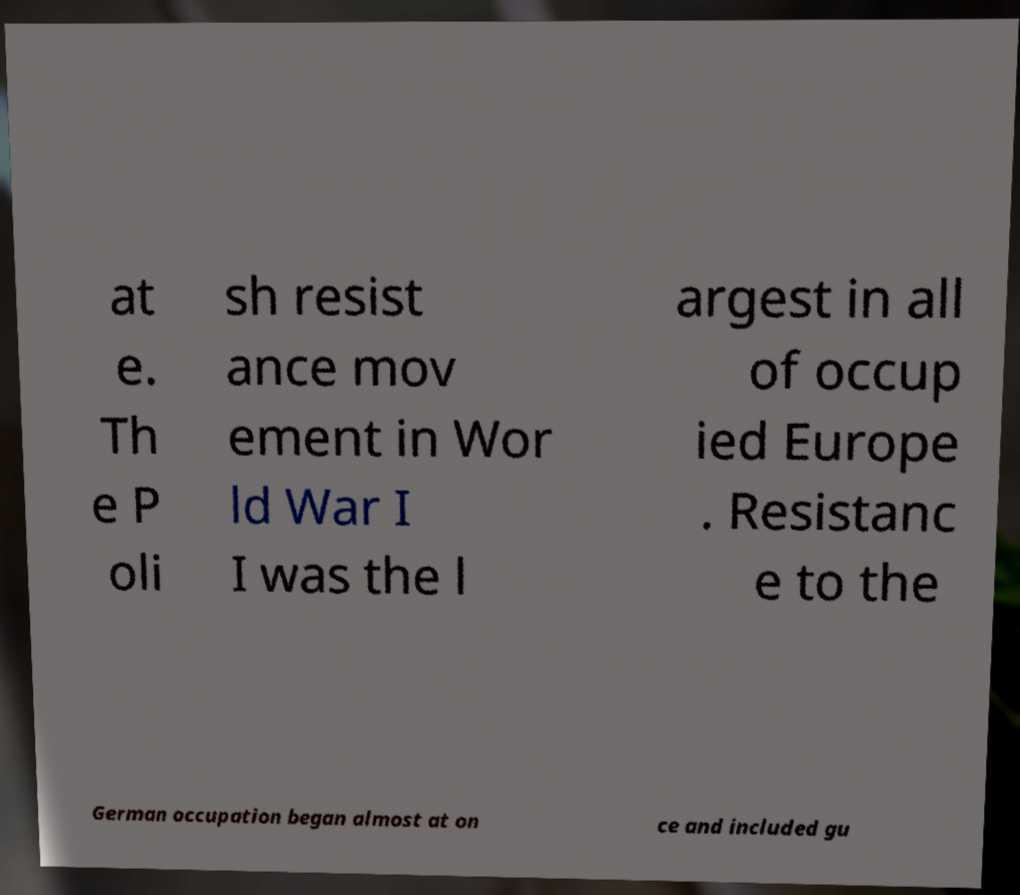I need the written content from this picture converted into text. Can you do that? at e. Th e P oli sh resist ance mov ement in Wor ld War I I was the l argest in all of occup ied Europe . Resistanc e to the German occupation began almost at on ce and included gu 